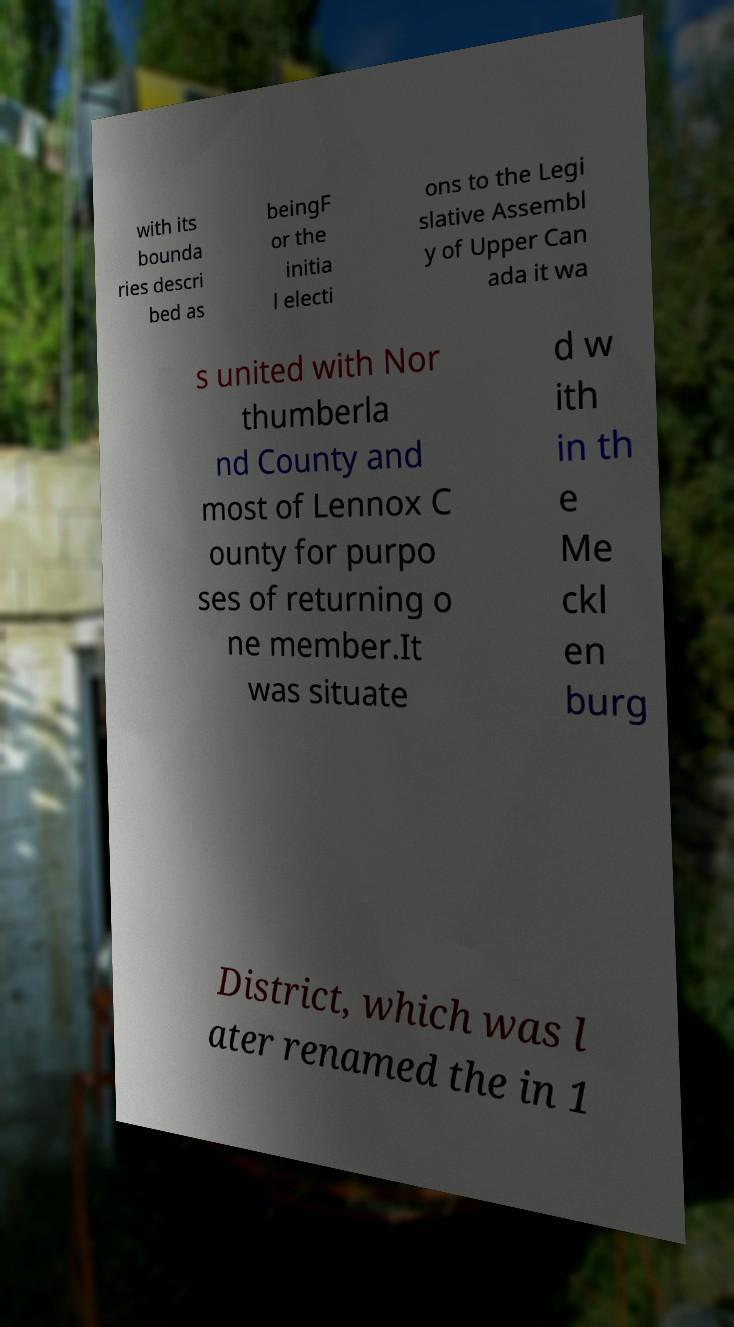Could you extract and type out the text from this image? with its bounda ries descri bed as beingF or the initia l electi ons to the Legi slative Assembl y of Upper Can ada it wa s united with Nor thumberla nd County and most of Lennox C ounty for purpo ses of returning o ne member.It was situate d w ith in th e Me ckl en burg District, which was l ater renamed the in 1 